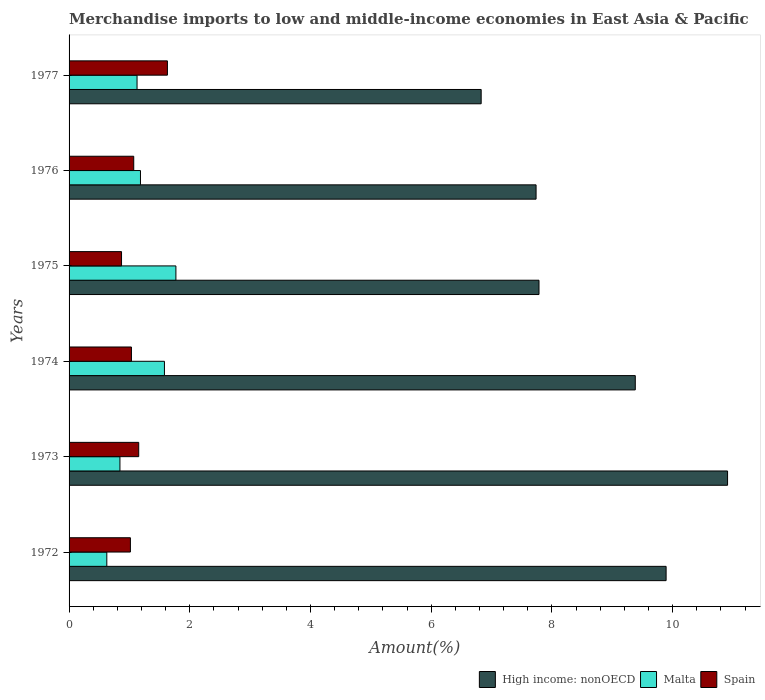How many different coloured bars are there?
Provide a short and direct response. 3. How many bars are there on the 4th tick from the top?
Keep it short and to the point. 3. In how many cases, is the number of bars for a given year not equal to the number of legend labels?
Your answer should be compact. 0. What is the percentage of amount earned from merchandise imports in Malta in 1975?
Your answer should be compact. 1.77. Across all years, what is the maximum percentage of amount earned from merchandise imports in Malta?
Your answer should be compact. 1.77. Across all years, what is the minimum percentage of amount earned from merchandise imports in Spain?
Give a very brief answer. 0.87. In which year was the percentage of amount earned from merchandise imports in High income: nonOECD maximum?
Offer a very short reply. 1973. What is the total percentage of amount earned from merchandise imports in Spain in the graph?
Your answer should be compact. 6.77. What is the difference between the percentage of amount earned from merchandise imports in Spain in 1973 and that in 1976?
Ensure brevity in your answer.  0.08. What is the difference between the percentage of amount earned from merchandise imports in High income: nonOECD in 1976 and the percentage of amount earned from merchandise imports in Malta in 1974?
Your answer should be compact. 6.16. What is the average percentage of amount earned from merchandise imports in Spain per year?
Your response must be concise. 1.13. In the year 1973, what is the difference between the percentage of amount earned from merchandise imports in Malta and percentage of amount earned from merchandise imports in High income: nonOECD?
Provide a short and direct response. -10.07. In how many years, is the percentage of amount earned from merchandise imports in High income: nonOECD greater than 6.8 %?
Keep it short and to the point. 6. What is the ratio of the percentage of amount earned from merchandise imports in Spain in 1973 to that in 1977?
Keep it short and to the point. 0.71. What is the difference between the highest and the second highest percentage of amount earned from merchandise imports in Spain?
Ensure brevity in your answer.  0.48. What is the difference between the highest and the lowest percentage of amount earned from merchandise imports in Malta?
Make the answer very short. 1.14. In how many years, is the percentage of amount earned from merchandise imports in Malta greater than the average percentage of amount earned from merchandise imports in Malta taken over all years?
Provide a succinct answer. 2. Is it the case that in every year, the sum of the percentage of amount earned from merchandise imports in Malta and percentage of amount earned from merchandise imports in High income: nonOECD is greater than the percentage of amount earned from merchandise imports in Spain?
Your response must be concise. Yes. Are all the bars in the graph horizontal?
Your response must be concise. Yes. How many years are there in the graph?
Provide a succinct answer. 6. What is the difference between two consecutive major ticks on the X-axis?
Provide a short and direct response. 2. Are the values on the major ticks of X-axis written in scientific E-notation?
Keep it short and to the point. No. Does the graph contain grids?
Provide a short and direct response. No. How many legend labels are there?
Your answer should be very brief. 3. What is the title of the graph?
Ensure brevity in your answer.  Merchandise imports to low and middle-income economies in East Asia & Pacific. What is the label or title of the X-axis?
Provide a short and direct response. Amount(%). What is the label or title of the Y-axis?
Your answer should be very brief. Years. What is the Amount(%) in High income: nonOECD in 1972?
Keep it short and to the point. 9.89. What is the Amount(%) in Malta in 1972?
Give a very brief answer. 0.63. What is the Amount(%) of Spain in 1972?
Your answer should be very brief. 1.02. What is the Amount(%) in High income: nonOECD in 1973?
Provide a short and direct response. 10.91. What is the Amount(%) in Malta in 1973?
Offer a terse response. 0.84. What is the Amount(%) of Spain in 1973?
Your response must be concise. 1.15. What is the Amount(%) of High income: nonOECD in 1974?
Ensure brevity in your answer.  9.38. What is the Amount(%) of Malta in 1974?
Give a very brief answer. 1.58. What is the Amount(%) of Spain in 1974?
Provide a short and direct response. 1.03. What is the Amount(%) of High income: nonOECD in 1975?
Provide a short and direct response. 7.79. What is the Amount(%) of Malta in 1975?
Your response must be concise. 1.77. What is the Amount(%) in Spain in 1975?
Offer a very short reply. 0.87. What is the Amount(%) of High income: nonOECD in 1976?
Make the answer very short. 7.74. What is the Amount(%) of Malta in 1976?
Provide a short and direct response. 1.18. What is the Amount(%) in Spain in 1976?
Your answer should be very brief. 1.07. What is the Amount(%) of High income: nonOECD in 1977?
Offer a terse response. 6.83. What is the Amount(%) of Malta in 1977?
Provide a succinct answer. 1.13. What is the Amount(%) of Spain in 1977?
Give a very brief answer. 1.63. Across all years, what is the maximum Amount(%) in High income: nonOECD?
Offer a very short reply. 10.91. Across all years, what is the maximum Amount(%) of Malta?
Your response must be concise. 1.77. Across all years, what is the maximum Amount(%) of Spain?
Your response must be concise. 1.63. Across all years, what is the minimum Amount(%) of High income: nonOECD?
Offer a very short reply. 6.83. Across all years, what is the minimum Amount(%) in Malta?
Offer a very short reply. 0.63. Across all years, what is the minimum Amount(%) of Spain?
Give a very brief answer. 0.87. What is the total Amount(%) in High income: nonOECD in the graph?
Make the answer very short. 52.53. What is the total Amount(%) of Malta in the graph?
Offer a terse response. 7.13. What is the total Amount(%) in Spain in the graph?
Your response must be concise. 6.77. What is the difference between the Amount(%) of High income: nonOECD in 1972 and that in 1973?
Offer a terse response. -1.02. What is the difference between the Amount(%) of Malta in 1972 and that in 1973?
Your response must be concise. -0.22. What is the difference between the Amount(%) in Spain in 1972 and that in 1973?
Provide a short and direct response. -0.14. What is the difference between the Amount(%) of High income: nonOECD in 1972 and that in 1974?
Ensure brevity in your answer.  0.51. What is the difference between the Amount(%) of Malta in 1972 and that in 1974?
Keep it short and to the point. -0.95. What is the difference between the Amount(%) of Spain in 1972 and that in 1974?
Your answer should be very brief. -0.02. What is the difference between the Amount(%) of High income: nonOECD in 1972 and that in 1975?
Offer a very short reply. 2.11. What is the difference between the Amount(%) of Malta in 1972 and that in 1975?
Keep it short and to the point. -1.14. What is the difference between the Amount(%) in Spain in 1972 and that in 1975?
Provide a short and direct response. 0.15. What is the difference between the Amount(%) of High income: nonOECD in 1972 and that in 1976?
Offer a terse response. 2.15. What is the difference between the Amount(%) of Malta in 1972 and that in 1976?
Offer a terse response. -0.56. What is the difference between the Amount(%) of Spain in 1972 and that in 1976?
Your answer should be very brief. -0.06. What is the difference between the Amount(%) in High income: nonOECD in 1972 and that in 1977?
Keep it short and to the point. 3.06. What is the difference between the Amount(%) of Malta in 1972 and that in 1977?
Your response must be concise. -0.5. What is the difference between the Amount(%) of Spain in 1972 and that in 1977?
Keep it short and to the point. -0.61. What is the difference between the Amount(%) of High income: nonOECD in 1973 and that in 1974?
Offer a very short reply. 1.53. What is the difference between the Amount(%) in Malta in 1973 and that in 1974?
Ensure brevity in your answer.  -0.74. What is the difference between the Amount(%) in Spain in 1973 and that in 1974?
Make the answer very short. 0.12. What is the difference between the Amount(%) of High income: nonOECD in 1973 and that in 1975?
Give a very brief answer. 3.12. What is the difference between the Amount(%) in Malta in 1973 and that in 1975?
Provide a succinct answer. -0.93. What is the difference between the Amount(%) of Spain in 1973 and that in 1975?
Provide a succinct answer. 0.28. What is the difference between the Amount(%) of High income: nonOECD in 1973 and that in 1976?
Offer a very short reply. 3.17. What is the difference between the Amount(%) in Malta in 1973 and that in 1976?
Offer a terse response. -0.34. What is the difference between the Amount(%) in Spain in 1973 and that in 1976?
Your response must be concise. 0.08. What is the difference between the Amount(%) in High income: nonOECD in 1973 and that in 1977?
Offer a very short reply. 4.08. What is the difference between the Amount(%) in Malta in 1973 and that in 1977?
Make the answer very short. -0.28. What is the difference between the Amount(%) in Spain in 1973 and that in 1977?
Your answer should be compact. -0.48. What is the difference between the Amount(%) of High income: nonOECD in 1974 and that in 1975?
Ensure brevity in your answer.  1.59. What is the difference between the Amount(%) in Malta in 1974 and that in 1975?
Your response must be concise. -0.19. What is the difference between the Amount(%) of Spain in 1974 and that in 1975?
Your answer should be very brief. 0.16. What is the difference between the Amount(%) of High income: nonOECD in 1974 and that in 1976?
Keep it short and to the point. 1.64. What is the difference between the Amount(%) of Malta in 1974 and that in 1976?
Provide a succinct answer. 0.4. What is the difference between the Amount(%) of Spain in 1974 and that in 1976?
Provide a succinct answer. -0.04. What is the difference between the Amount(%) in High income: nonOECD in 1974 and that in 1977?
Your answer should be compact. 2.55. What is the difference between the Amount(%) in Malta in 1974 and that in 1977?
Provide a short and direct response. 0.45. What is the difference between the Amount(%) of Spain in 1974 and that in 1977?
Ensure brevity in your answer.  -0.6. What is the difference between the Amount(%) in High income: nonOECD in 1975 and that in 1976?
Keep it short and to the point. 0.05. What is the difference between the Amount(%) of Malta in 1975 and that in 1976?
Provide a succinct answer. 0.59. What is the difference between the Amount(%) in Spain in 1975 and that in 1976?
Provide a succinct answer. -0.2. What is the difference between the Amount(%) in High income: nonOECD in 1975 and that in 1977?
Ensure brevity in your answer.  0.96. What is the difference between the Amount(%) of Malta in 1975 and that in 1977?
Your response must be concise. 0.64. What is the difference between the Amount(%) of Spain in 1975 and that in 1977?
Your answer should be compact. -0.76. What is the difference between the Amount(%) in High income: nonOECD in 1976 and that in 1977?
Ensure brevity in your answer.  0.91. What is the difference between the Amount(%) in Malta in 1976 and that in 1977?
Provide a short and direct response. 0.06. What is the difference between the Amount(%) in Spain in 1976 and that in 1977?
Keep it short and to the point. -0.56. What is the difference between the Amount(%) in High income: nonOECD in 1972 and the Amount(%) in Malta in 1973?
Ensure brevity in your answer.  9.05. What is the difference between the Amount(%) in High income: nonOECD in 1972 and the Amount(%) in Spain in 1973?
Your response must be concise. 8.74. What is the difference between the Amount(%) of Malta in 1972 and the Amount(%) of Spain in 1973?
Make the answer very short. -0.53. What is the difference between the Amount(%) in High income: nonOECD in 1972 and the Amount(%) in Malta in 1974?
Your answer should be compact. 8.31. What is the difference between the Amount(%) of High income: nonOECD in 1972 and the Amount(%) of Spain in 1974?
Offer a terse response. 8.86. What is the difference between the Amount(%) in Malta in 1972 and the Amount(%) in Spain in 1974?
Keep it short and to the point. -0.41. What is the difference between the Amount(%) of High income: nonOECD in 1972 and the Amount(%) of Malta in 1975?
Provide a succinct answer. 8.12. What is the difference between the Amount(%) in High income: nonOECD in 1972 and the Amount(%) in Spain in 1975?
Provide a short and direct response. 9.02. What is the difference between the Amount(%) in Malta in 1972 and the Amount(%) in Spain in 1975?
Offer a terse response. -0.24. What is the difference between the Amount(%) of High income: nonOECD in 1972 and the Amount(%) of Malta in 1976?
Ensure brevity in your answer.  8.71. What is the difference between the Amount(%) of High income: nonOECD in 1972 and the Amount(%) of Spain in 1976?
Your answer should be compact. 8.82. What is the difference between the Amount(%) of Malta in 1972 and the Amount(%) of Spain in 1976?
Keep it short and to the point. -0.45. What is the difference between the Amount(%) of High income: nonOECD in 1972 and the Amount(%) of Malta in 1977?
Ensure brevity in your answer.  8.76. What is the difference between the Amount(%) of High income: nonOECD in 1972 and the Amount(%) of Spain in 1977?
Make the answer very short. 8.26. What is the difference between the Amount(%) of Malta in 1972 and the Amount(%) of Spain in 1977?
Provide a short and direct response. -1. What is the difference between the Amount(%) in High income: nonOECD in 1973 and the Amount(%) in Malta in 1974?
Your response must be concise. 9.33. What is the difference between the Amount(%) of High income: nonOECD in 1973 and the Amount(%) of Spain in 1974?
Offer a very short reply. 9.88. What is the difference between the Amount(%) of Malta in 1973 and the Amount(%) of Spain in 1974?
Keep it short and to the point. -0.19. What is the difference between the Amount(%) of High income: nonOECD in 1973 and the Amount(%) of Malta in 1975?
Keep it short and to the point. 9.14. What is the difference between the Amount(%) of High income: nonOECD in 1973 and the Amount(%) of Spain in 1975?
Your response must be concise. 10.04. What is the difference between the Amount(%) of Malta in 1973 and the Amount(%) of Spain in 1975?
Your response must be concise. -0.03. What is the difference between the Amount(%) of High income: nonOECD in 1973 and the Amount(%) of Malta in 1976?
Keep it short and to the point. 9.73. What is the difference between the Amount(%) of High income: nonOECD in 1973 and the Amount(%) of Spain in 1976?
Give a very brief answer. 9.84. What is the difference between the Amount(%) in Malta in 1973 and the Amount(%) in Spain in 1976?
Keep it short and to the point. -0.23. What is the difference between the Amount(%) of High income: nonOECD in 1973 and the Amount(%) of Malta in 1977?
Your response must be concise. 9.78. What is the difference between the Amount(%) of High income: nonOECD in 1973 and the Amount(%) of Spain in 1977?
Give a very brief answer. 9.28. What is the difference between the Amount(%) of Malta in 1973 and the Amount(%) of Spain in 1977?
Offer a terse response. -0.79. What is the difference between the Amount(%) of High income: nonOECD in 1974 and the Amount(%) of Malta in 1975?
Ensure brevity in your answer.  7.61. What is the difference between the Amount(%) of High income: nonOECD in 1974 and the Amount(%) of Spain in 1975?
Ensure brevity in your answer.  8.51. What is the difference between the Amount(%) in Malta in 1974 and the Amount(%) in Spain in 1975?
Provide a succinct answer. 0.71. What is the difference between the Amount(%) of High income: nonOECD in 1974 and the Amount(%) of Malta in 1976?
Provide a succinct answer. 8.2. What is the difference between the Amount(%) of High income: nonOECD in 1974 and the Amount(%) of Spain in 1976?
Provide a short and direct response. 8.31. What is the difference between the Amount(%) in Malta in 1974 and the Amount(%) in Spain in 1976?
Offer a terse response. 0.51. What is the difference between the Amount(%) in High income: nonOECD in 1974 and the Amount(%) in Malta in 1977?
Ensure brevity in your answer.  8.25. What is the difference between the Amount(%) of High income: nonOECD in 1974 and the Amount(%) of Spain in 1977?
Provide a succinct answer. 7.75. What is the difference between the Amount(%) of Malta in 1974 and the Amount(%) of Spain in 1977?
Keep it short and to the point. -0.05. What is the difference between the Amount(%) in High income: nonOECD in 1975 and the Amount(%) in Malta in 1976?
Make the answer very short. 6.6. What is the difference between the Amount(%) of High income: nonOECD in 1975 and the Amount(%) of Spain in 1976?
Your response must be concise. 6.71. What is the difference between the Amount(%) in Malta in 1975 and the Amount(%) in Spain in 1976?
Ensure brevity in your answer.  0.7. What is the difference between the Amount(%) of High income: nonOECD in 1975 and the Amount(%) of Malta in 1977?
Your answer should be very brief. 6.66. What is the difference between the Amount(%) of High income: nonOECD in 1975 and the Amount(%) of Spain in 1977?
Your response must be concise. 6.16. What is the difference between the Amount(%) in Malta in 1975 and the Amount(%) in Spain in 1977?
Your answer should be compact. 0.14. What is the difference between the Amount(%) in High income: nonOECD in 1976 and the Amount(%) in Malta in 1977?
Ensure brevity in your answer.  6.61. What is the difference between the Amount(%) in High income: nonOECD in 1976 and the Amount(%) in Spain in 1977?
Your answer should be compact. 6.11. What is the difference between the Amount(%) in Malta in 1976 and the Amount(%) in Spain in 1977?
Keep it short and to the point. -0.45. What is the average Amount(%) of High income: nonOECD per year?
Your answer should be very brief. 8.76. What is the average Amount(%) in Malta per year?
Provide a succinct answer. 1.19. What is the average Amount(%) of Spain per year?
Offer a very short reply. 1.13. In the year 1972, what is the difference between the Amount(%) in High income: nonOECD and Amount(%) in Malta?
Your answer should be very brief. 9.27. In the year 1972, what is the difference between the Amount(%) in High income: nonOECD and Amount(%) in Spain?
Offer a very short reply. 8.88. In the year 1972, what is the difference between the Amount(%) of Malta and Amount(%) of Spain?
Ensure brevity in your answer.  -0.39. In the year 1973, what is the difference between the Amount(%) of High income: nonOECD and Amount(%) of Malta?
Give a very brief answer. 10.07. In the year 1973, what is the difference between the Amount(%) of High income: nonOECD and Amount(%) of Spain?
Your answer should be compact. 9.76. In the year 1973, what is the difference between the Amount(%) in Malta and Amount(%) in Spain?
Your answer should be very brief. -0.31. In the year 1974, what is the difference between the Amount(%) of High income: nonOECD and Amount(%) of Malta?
Offer a terse response. 7.8. In the year 1974, what is the difference between the Amount(%) of High income: nonOECD and Amount(%) of Spain?
Offer a terse response. 8.35. In the year 1974, what is the difference between the Amount(%) in Malta and Amount(%) in Spain?
Provide a succinct answer. 0.55. In the year 1975, what is the difference between the Amount(%) of High income: nonOECD and Amount(%) of Malta?
Provide a succinct answer. 6.02. In the year 1975, what is the difference between the Amount(%) in High income: nonOECD and Amount(%) in Spain?
Provide a succinct answer. 6.92. In the year 1975, what is the difference between the Amount(%) in Malta and Amount(%) in Spain?
Make the answer very short. 0.9. In the year 1976, what is the difference between the Amount(%) in High income: nonOECD and Amount(%) in Malta?
Keep it short and to the point. 6.55. In the year 1976, what is the difference between the Amount(%) of High income: nonOECD and Amount(%) of Spain?
Offer a terse response. 6.67. In the year 1976, what is the difference between the Amount(%) in Malta and Amount(%) in Spain?
Your answer should be compact. 0.11. In the year 1977, what is the difference between the Amount(%) of High income: nonOECD and Amount(%) of Malta?
Provide a succinct answer. 5.7. In the year 1977, what is the difference between the Amount(%) of High income: nonOECD and Amount(%) of Spain?
Keep it short and to the point. 5.2. In the year 1977, what is the difference between the Amount(%) of Malta and Amount(%) of Spain?
Your response must be concise. -0.5. What is the ratio of the Amount(%) of High income: nonOECD in 1972 to that in 1973?
Make the answer very short. 0.91. What is the ratio of the Amount(%) in Malta in 1972 to that in 1973?
Your answer should be compact. 0.74. What is the ratio of the Amount(%) of Spain in 1972 to that in 1973?
Provide a short and direct response. 0.88. What is the ratio of the Amount(%) in High income: nonOECD in 1972 to that in 1974?
Offer a very short reply. 1.05. What is the ratio of the Amount(%) in Malta in 1972 to that in 1974?
Keep it short and to the point. 0.4. What is the ratio of the Amount(%) of Spain in 1972 to that in 1974?
Make the answer very short. 0.98. What is the ratio of the Amount(%) of High income: nonOECD in 1972 to that in 1975?
Keep it short and to the point. 1.27. What is the ratio of the Amount(%) in Malta in 1972 to that in 1975?
Your answer should be compact. 0.35. What is the ratio of the Amount(%) of Spain in 1972 to that in 1975?
Ensure brevity in your answer.  1.17. What is the ratio of the Amount(%) in High income: nonOECD in 1972 to that in 1976?
Make the answer very short. 1.28. What is the ratio of the Amount(%) of Malta in 1972 to that in 1976?
Ensure brevity in your answer.  0.53. What is the ratio of the Amount(%) in Spain in 1972 to that in 1976?
Offer a very short reply. 0.95. What is the ratio of the Amount(%) in High income: nonOECD in 1972 to that in 1977?
Ensure brevity in your answer.  1.45. What is the ratio of the Amount(%) of Malta in 1972 to that in 1977?
Ensure brevity in your answer.  0.56. What is the ratio of the Amount(%) in Spain in 1972 to that in 1977?
Your response must be concise. 0.62. What is the ratio of the Amount(%) of High income: nonOECD in 1973 to that in 1974?
Your response must be concise. 1.16. What is the ratio of the Amount(%) of Malta in 1973 to that in 1974?
Your answer should be compact. 0.53. What is the ratio of the Amount(%) in Spain in 1973 to that in 1974?
Provide a short and direct response. 1.12. What is the ratio of the Amount(%) of High income: nonOECD in 1973 to that in 1975?
Provide a succinct answer. 1.4. What is the ratio of the Amount(%) of Malta in 1973 to that in 1975?
Your answer should be very brief. 0.48. What is the ratio of the Amount(%) of Spain in 1973 to that in 1975?
Offer a very short reply. 1.33. What is the ratio of the Amount(%) of High income: nonOECD in 1973 to that in 1976?
Make the answer very short. 1.41. What is the ratio of the Amount(%) of Malta in 1973 to that in 1976?
Your answer should be compact. 0.71. What is the ratio of the Amount(%) in Spain in 1973 to that in 1976?
Keep it short and to the point. 1.08. What is the ratio of the Amount(%) in High income: nonOECD in 1973 to that in 1977?
Your answer should be very brief. 1.6. What is the ratio of the Amount(%) of Malta in 1973 to that in 1977?
Your answer should be compact. 0.75. What is the ratio of the Amount(%) in Spain in 1973 to that in 1977?
Provide a succinct answer. 0.71. What is the ratio of the Amount(%) of High income: nonOECD in 1974 to that in 1975?
Ensure brevity in your answer.  1.2. What is the ratio of the Amount(%) in Malta in 1974 to that in 1975?
Make the answer very short. 0.89. What is the ratio of the Amount(%) in Spain in 1974 to that in 1975?
Your response must be concise. 1.19. What is the ratio of the Amount(%) in High income: nonOECD in 1974 to that in 1976?
Your response must be concise. 1.21. What is the ratio of the Amount(%) of Malta in 1974 to that in 1976?
Make the answer very short. 1.34. What is the ratio of the Amount(%) in Spain in 1974 to that in 1976?
Keep it short and to the point. 0.96. What is the ratio of the Amount(%) of High income: nonOECD in 1974 to that in 1977?
Ensure brevity in your answer.  1.37. What is the ratio of the Amount(%) in Malta in 1974 to that in 1977?
Provide a succinct answer. 1.4. What is the ratio of the Amount(%) of Spain in 1974 to that in 1977?
Keep it short and to the point. 0.63. What is the ratio of the Amount(%) of Malta in 1975 to that in 1976?
Provide a succinct answer. 1.5. What is the ratio of the Amount(%) in Spain in 1975 to that in 1976?
Your response must be concise. 0.81. What is the ratio of the Amount(%) in High income: nonOECD in 1975 to that in 1977?
Your answer should be very brief. 1.14. What is the ratio of the Amount(%) of Malta in 1975 to that in 1977?
Your answer should be compact. 1.57. What is the ratio of the Amount(%) of Spain in 1975 to that in 1977?
Provide a succinct answer. 0.53. What is the ratio of the Amount(%) in High income: nonOECD in 1976 to that in 1977?
Give a very brief answer. 1.13. What is the ratio of the Amount(%) of Malta in 1976 to that in 1977?
Keep it short and to the point. 1.05. What is the ratio of the Amount(%) of Spain in 1976 to that in 1977?
Provide a succinct answer. 0.66. What is the difference between the highest and the second highest Amount(%) of High income: nonOECD?
Offer a terse response. 1.02. What is the difference between the highest and the second highest Amount(%) in Malta?
Give a very brief answer. 0.19. What is the difference between the highest and the second highest Amount(%) of Spain?
Your response must be concise. 0.48. What is the difference between the highest and the lowest Amount(%) of High income: nonOECD?
Provide a short and direct response. 4.08. What is the difference between the highest and the lowest Amount(%) in Malta?
Offer a very short reply. 1.14. What is the difference between the highest and the lowest Amount(%) in Spain?
Your answer should be very brief. 0.76. 